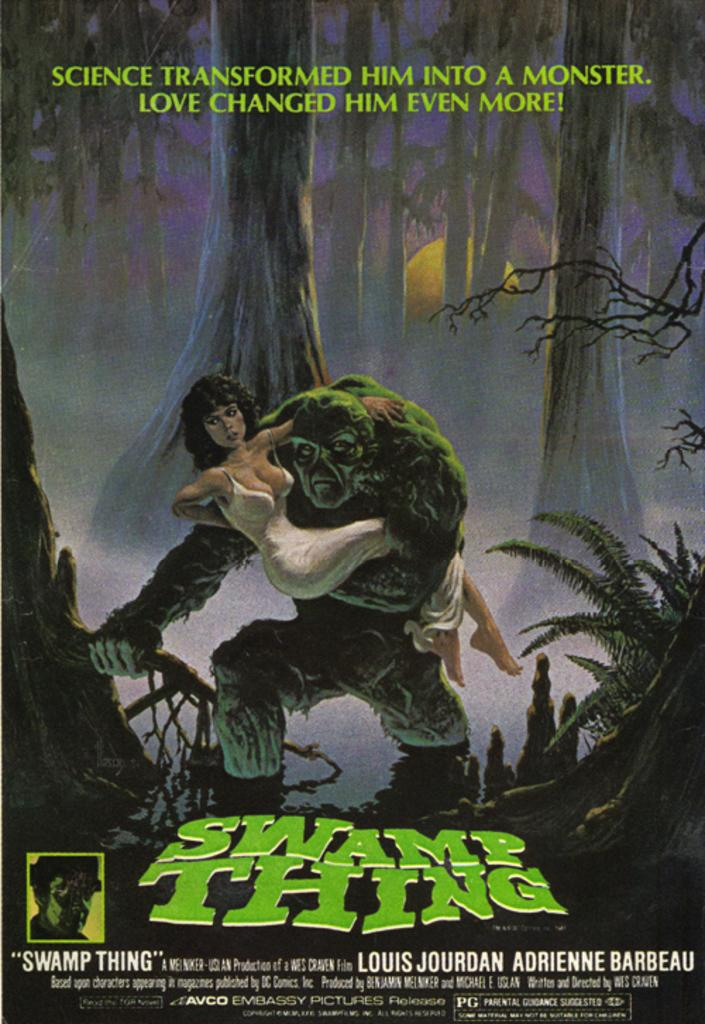<image>
Share a concise interpretation of the image provided. a poster for Swamp Thing holding a woman in a white dress 